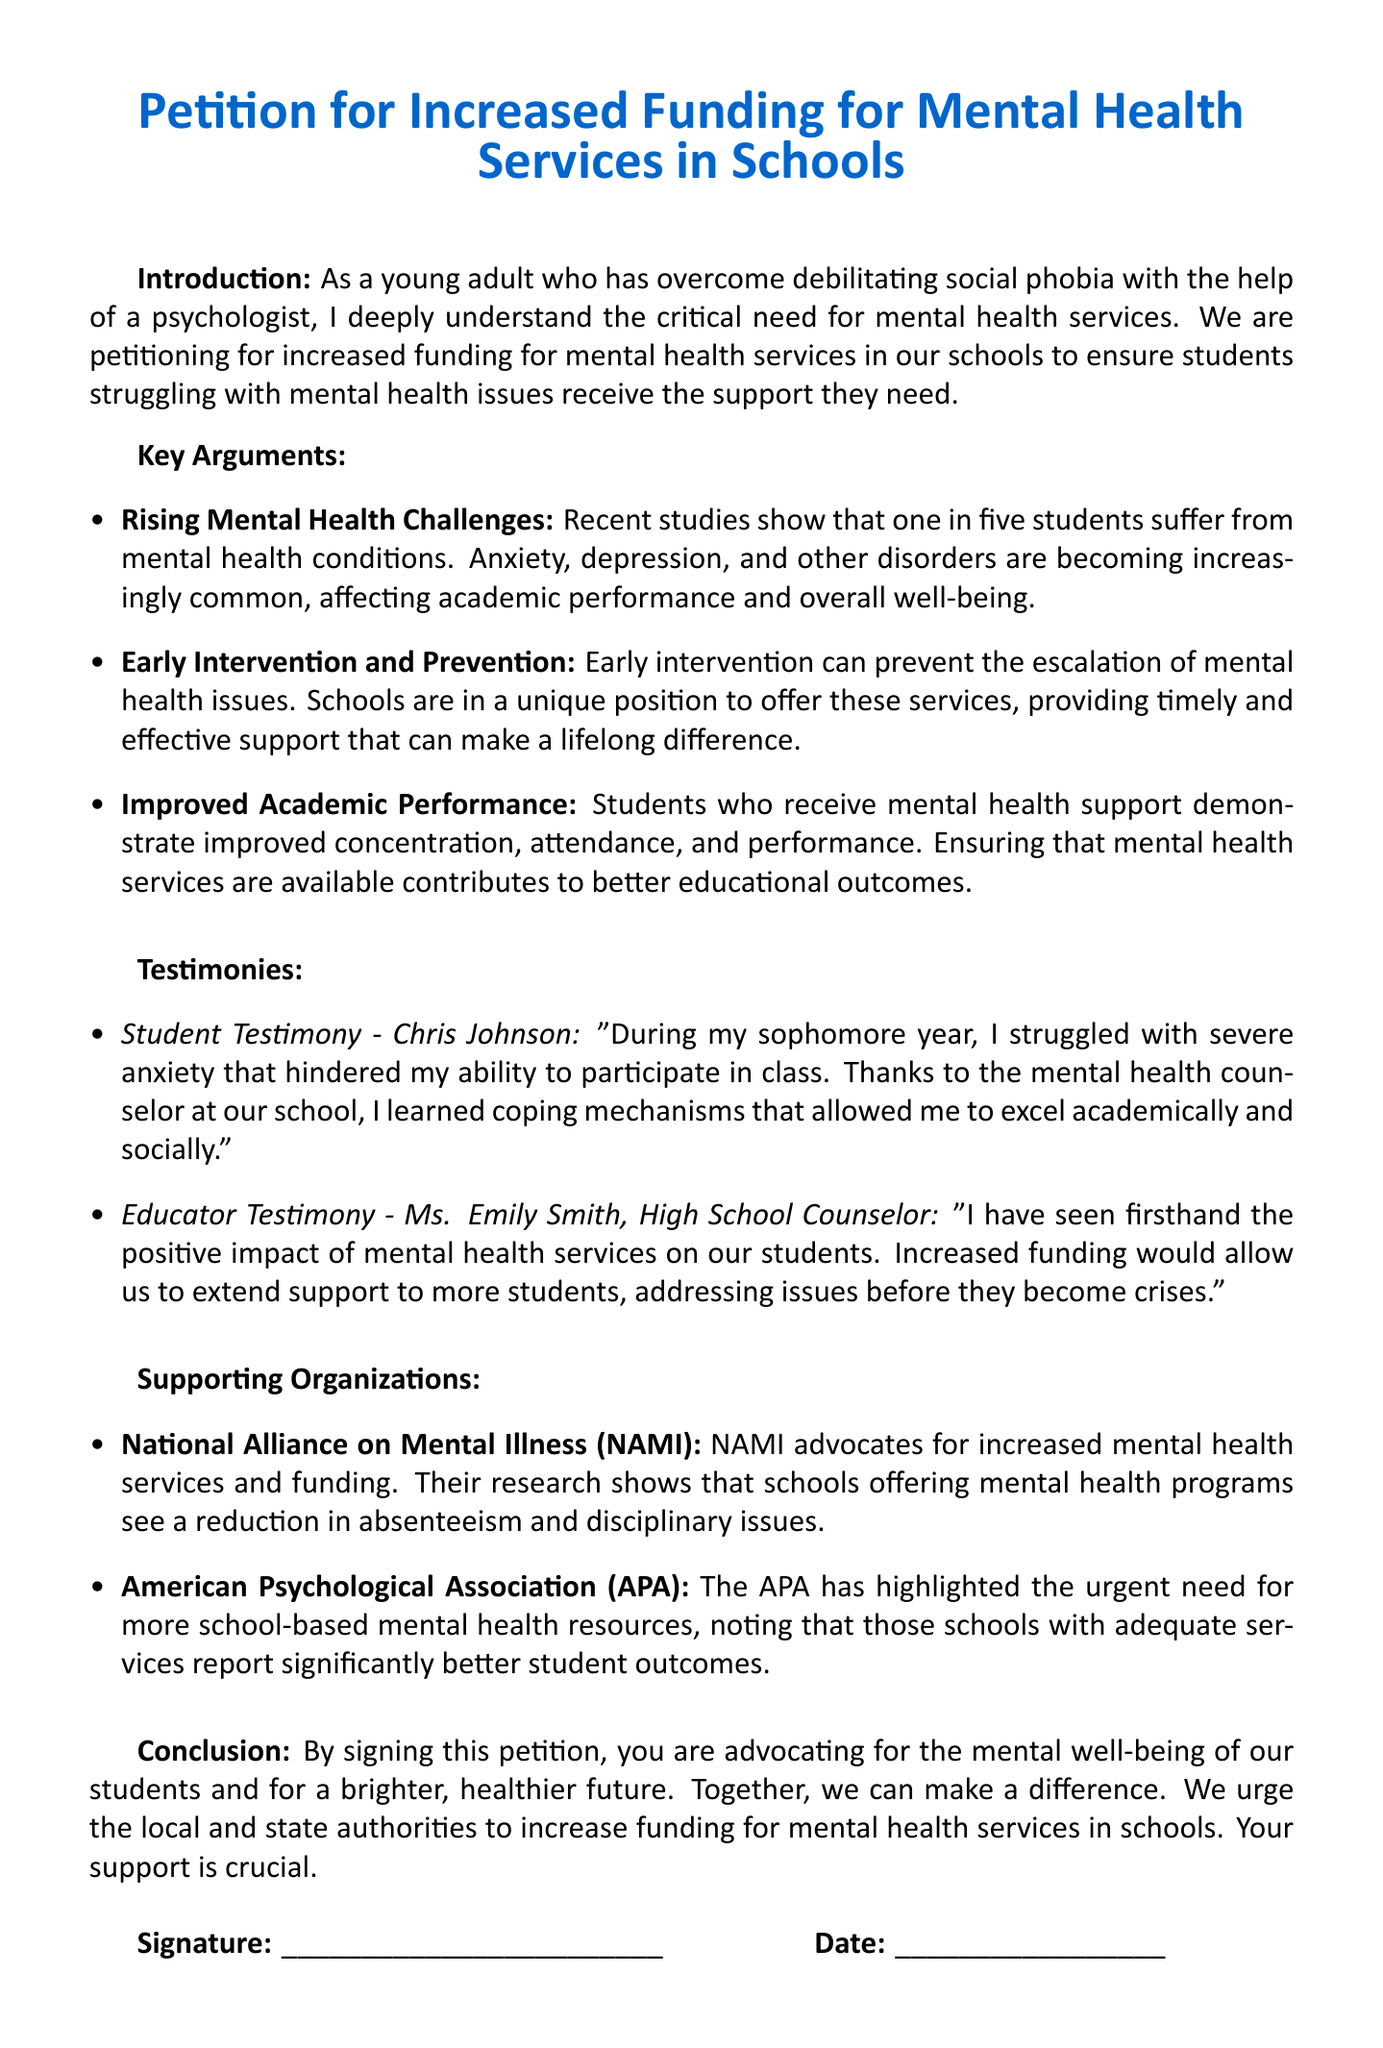What is the title of the petition? The title is clearly stated at the beginning of the document and is "Petition for Increased Funding for Mental Health Services in Schools."
Answer: Petition for Increased Funding for Mental Health Services in Schools How many students are said to suffer from mental health conditions? The document states that one in five students suffer from mental health conditions.
Answer: one in five Who provided a testimony as a high school counselor? The document mentions a testimony from Ms. Emily Smith, who is identified as a high school counselor.
Answer: Ms. Emily Smith What is one identified benefit of increased mental health funding? The petition lists improved academic performance as a benefit of increased mental health funding.
Answer: Improved Academic Performance Which organization advocates for increased mental health services? The National Alliance on Mental Illness (NAMI) is highlighted as an organization advocating for increased services.
Answer: National Alliance on Mental Illness (NAMI) What is the purpose of this petition? The purpose of the petition is to advocate for increased funding for mental health services in schools.
Answer: advocate for increased funding for mental health services in schools What do students who receive mental health support demonstrate? According to the document, students who receive mental health support demonstrate improved concentration, attendance, and performance.
Answer: improved concentration, attendance, and performance What type of support do schools provide regarding mental health? The document states that schools offer early intervention support for mental health issues.
Answer: early intervention support 